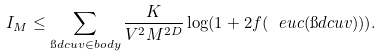Convert formula to latex. <formula><loc_0><loc_0><loc_500><loc_500>I _ { M } \leq \sum _ { \i d c { u } { v } \in b o d y } \frac { K } { V ^ { 2 } M ^ { 2 D } } \log ( 1 + 2 f ( \ e u c ( \i d c { u } { v } ) ) ) .</formula> 